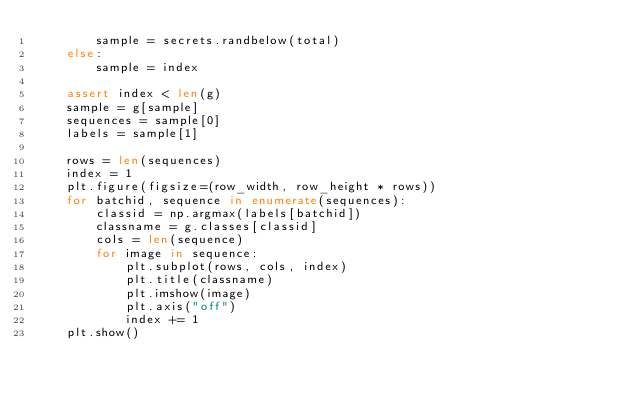<code> <loc_0><loc_0><loc_500><loc_500><_Python_>        sample = secrets.randbelow(total)
    else:
        sample = index

    assert index < len(g)
    sample = g[sample]
    sequences = sample[0]
    labels = sample[1]

    rows = len(sequences)
    index = 1
    plt.figure(figsize=(row_width, row_height * rows))
    for batchid, sequence in enumerate(sequences):
        classid = np.argmax(labels[batchid])
        classname = g.classes[classid]
        cols = len(sequence)
        for image in sequence:
            plt.subplot(rows, cols, index)
            plt.title(classname)
            plt.imshow(image)
            plt.axis("off")
            index += 1
    plt.show()
</code> 